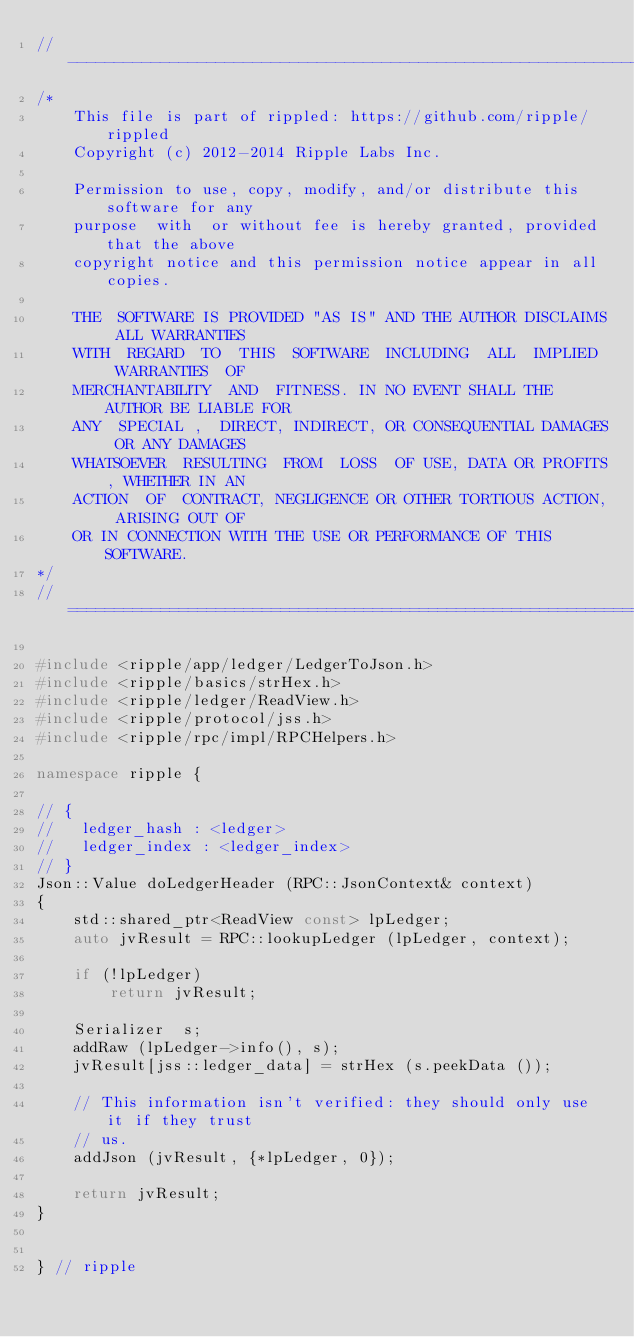Convert code to text. <code><loc_0><loc_0><loc_500><loc_500><_C++_>//------------------------------------------------------------------------------
/*
    This file is part of rippled: https://github.com/ripple/rippled
    Copyright (c) 2012-2014 Ripple Labs Inc.

    Permission to use, copy, modify, and/or distribute this software for any
    purpose  with  or without fee is hereby granted, provided that the above
    copyright notice and this permission notice appear in all copies.

    THE  SOFTWARE IS PROVIDED "AS IS" AND THE AUTHOR DISCLAIMS ALL WARRANTIES
    WITH  REGARD  TO  THIS  SOFTWARE  INCLUDING  ALL  IMPLIED  WARRANTIES  OF
    MERCHANTABILITY  AND  FITNESS. IN NO EVENT SHALL THE AUTHOR BE LIABLE FOR
    ANY  SPECIAL ,  DIRECT, INDIRECT, OR CONSEQUENTIAL DAMAGES OR ANY DAMAGES
    WHATSOEVER  RESULTING  FROM  LOSS  OF USE, DATA OR PROFITS, WHETHER IN AN
    ACTION  OF  CONTRACT, NEGLIGENCE OR OTHER TORTIOUS ACTION, ARISING OUT OF
    OR IN CONNECTION WITH THE USE OR PERFORMANCE OF THIS SOFTWARE.
*/
//==============================================================================

#include <ripple/app/ledger/LedgerToJson.h>
#include <ripple/basics/strHex.h>
#include <ripple/ledger/ReadView.h>
#include <ripple/protocol/jss.h>
#include <ripple/rpc/impl/RPCHelpers.h>

namespace ripple {

// {
//   ledger_hash : <ledger>
//   ledger_index : <ledger_index>
// }
Json::Value doLedgerHeader (RPC::JsonContext& context)
{
    std::shared_ptr<ReadView const> lpLedger;
    auto jvResult = RPC::lookupLedger (lpLedger, context);

    if (!lpLedger)
        return jvResult;

    Serializer  s;
    addRaw (lpLedger->info(), s);
    jvResult[jss::ledger_data] = strHex (s.peekData ());

    // This information isn't verified: they should only use it if they trust
    // us.
    addJson (jvResult, {*lpLedger, 0});

    return jvResult;
}


} // ripple
</code> 